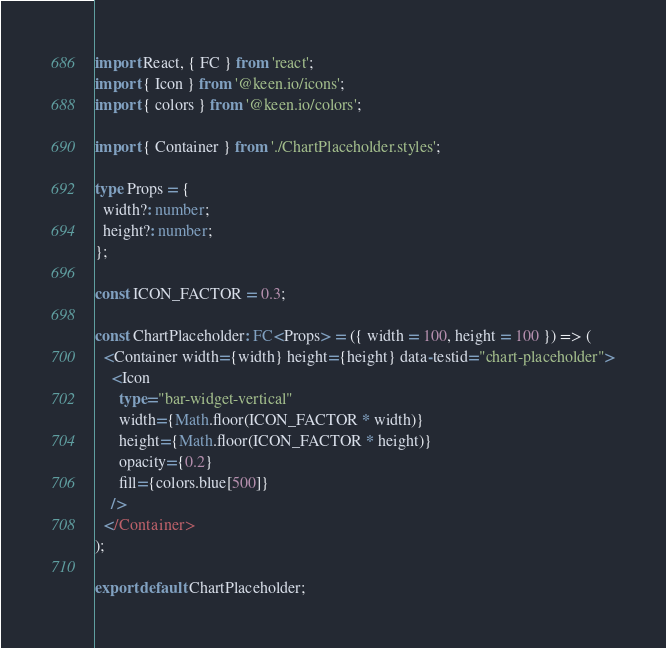Convert code to text. <code><loc_0><loc_0><loc_500><loc_500><_TypeScript_>import React, { FC } from 'react';
import { Icon } from '@keen.io/icons';
import { colors } from '@keen.io/colors';

import { Container } from './ChartPlaceholder.styles';

type Props = {
  width?: number;
  height?: number;
};

const ICON_FACTOR = 0.3;

const ChartPlaceholder: FC<Props> = ({ width = 100, height = 100 }) => (
  <Container width={width} height={height} data-testid="chart-placeholder">
    <Icon
      type="bar-widget-vertical"
      width={Math.floor(ICON_FACTOR * width)}
      height={Math.floor(ICON_FACTOR * height)}
      opacity={0.2}
      fill={colors.blue[500]}
    />
  </Container>
);

export default ChartPlaceholder;
</code> 